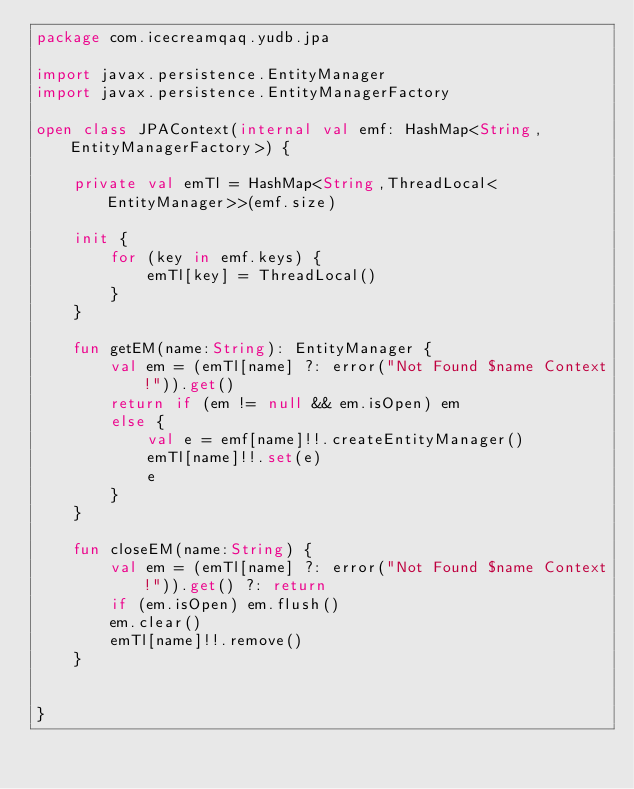Convert code to text. <code><loc_0><loc_0><loc_500><loc_500><_Kotlin_>package com.icecreamqaq.yudb.jpa

import javax.persistence.EntityManager
import javax.persistence.EntityManagerFactory

open class JPAContext(internal val emf: HashMap<String,EntityManagerFactory>) {

    private val emTl = HashMap<String,ThreadLocal<EntityManager>>(emf.size)

    init {
        for (key in emf.keys) {
            emTl[key] = ThreadLocal()
        }
    }

    fun getEM(name:String): EntityManager {
        val em = (emTl[name] ?: error("Not Found $name Context!")).get()
        return if (em != null && em.isOpen) em
        else {
            val e = emf[name]!!.createEntityManager()
            emTl[name]!!.set(e)
            e
        }
    }

    fun closeEM(name:String) {
        val em = (emTl[name] ?: error("Not Found $name Context!")).get() ?: return
        if (em.isOpen) em.flush()
        em.clear()
        emTl[name]!!.remove()
    }


}</code> 